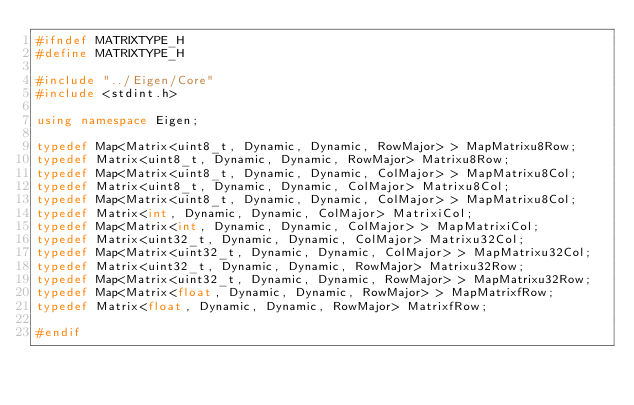<code> <loc_0><loc_0><loc_500><loc_500><_C++_>#ifndef MATRIXTYPE_H
#define MATRIXTYPE_H

#include "../Eigen/Core"
#include <stdint.h>

using namespace Eigen;

typedef Map<Matrix<uint8_t, Dynamic, Dynamic, RowMajor> > MapMatrixu8Row;
typedef Matrix<uint8_t, Dynamic, Dynamic, RowMajor> Matrixu8Row;
typedef Map<Matrix<uint8_t, Dynamic, Dynamic, ColMajor> > MapMatrixu8Col;
typedef Matrix<uint8_t, Dynamic, Dynamic, ColMajor> Matrixu8Col;
typedef Map<Matrix<uint8_t, Dynamic, Dynamic, ColMajor> > MapMatrixu8Col;
typedef Matrix<int, Dynamic, Dynamic, ColMajor> MatrixiCol;
typedef Map<Matrix<int, Dynamic, Dynamic, ColMajor> > MapMatrixiCol;
typedef Matrix<uint32_t, Dynamic, Dynamic, ColMajor> Matrixu32Col;
typedef Map<Matrix<uint32_t, Dynamic, Dynamic, ColMajor> > MapMatrixu32Col;
typedef Matrix<uint32_t, Dynamic, Dynamic, RowMajor> Matrixu32Row;
typedef Map<Matrix<uint32_t, Dynamic, Dynamic, RowMajor> > MapMatrixu32Row;
typedef Map<Matrix<float, Dynamic, Dynamic, RowMajor> > MapMatrixfRow;
typedef Matrix<float, Dynamic, Dynamic, RowMajor> MatrixfRow;

#endif
</code> 